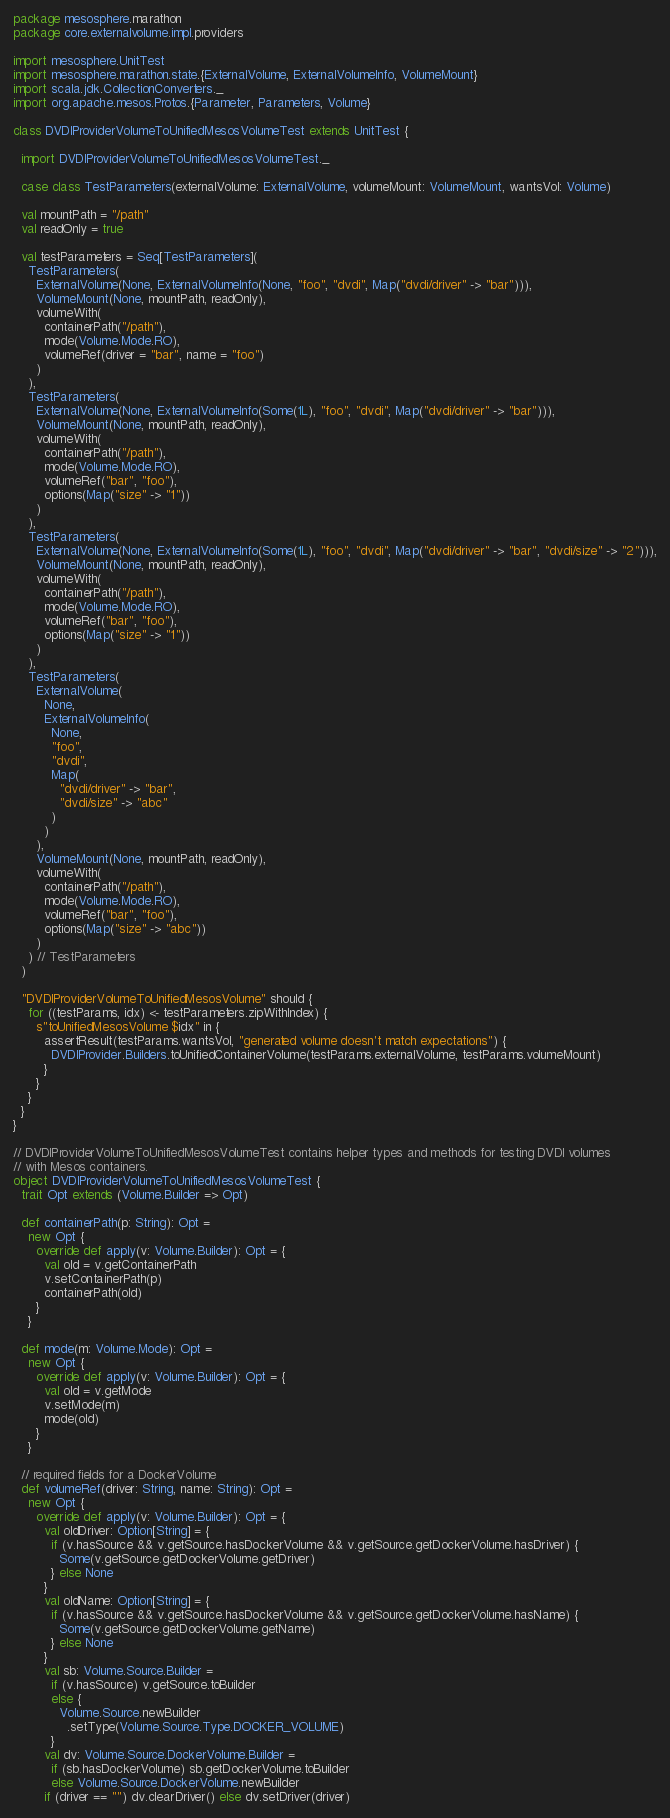Convert code to text. <code><loc_0><loc_0><loc_500><loc_500><_Scala_>package mesosphere.marathon
package core.externalvolume.impl.providers

import mesosphere.UnitTest
import mesosphere.marathon.state.{ExternalVolume, ExternalVolumeInfo, VolumeMount}
import scala.jdk.CollectionConverters._
import org.apache.mesos.Protos.{Parameter, Parameters, Volume}

class DVDIProviderVolumeToUnifiedMesosVolumeTest extends UnitTest {

  import DVDIProviderVolumeToUnifiedMesosVolumeTest._

  case class TestParameters(externalVolume: ExternalVolume, volumeMount: VolumeMount, wantsVol: Volume)

  val mountPath = "/path"
  val readOnly = true

  val testParameters = Seq[TestParameters](
    TestParameters(
      ExternalVolume(None, ExternalVolumeInfo(None, "foo", "dvdi", Map("dvdi/driver" -> "bar"))),
      VolumeMount(None, mountPath, readOnly),
      volumeWith(
        containerPath("/path"),
        mode(Volume.Mode.RO),
        volumeRef(driver = "bar", name = "foo")
      )
    ),
    TestParameters(
      ExternalVolume(None, ExternalVolumeInfo(Some(1L), "foo", "dvdi", Map("dvdi/driver" -> "bar"))),
      VolumeMount(None, mountPath, readOnly),
      volumeWith(
        containerPath("/path"),
        mode(Volume.Mode.RO),
        volumeRef("bar", "foo"),
        options(Map("size" -> "1"))
      )
    ),
    TestParameters(
      ExternalVolume(None, ExternalVolumeInfo(Some(1L), "foo", "dvdi", Map("dvdi/driver" -> "bar", "dvdi/size" -> "2"))),
      VolumeMount(None, mountPath, readOnly),
      volumeWith(
        containerPath("/path"),
        mode(Volume.Mode.RO),
        volumeRef("bar", "foo"),
        options(Map("size" -> "1"))
      )
    ),
    TestParameters(
      ExternalVolume(
        None,
        ExternalVolumeInfo(
          None,
          "foo",
          "dvdi",
          Map(
            "dvdi/driver" -> "bar",
            "dvdi/size" -> "abc"
          )
        )
      ),
      VolumeMount(None, mountPath, readOnly),
      volumeWith(
        containerPath("/path"),
        mode(Volume.Mode.RO),
        volumeRef("bar", "foo"),
        options(Map("size" -> "abc"))
      )
    ) // TestParameters
  )

  "DVDIProviderVolumeToUnifiedMesosVolume" should {
    for ((testParams, idx) <- testParameters.zipWithIndex) {
      s"toUnifiedMesosVolume $idx" in {
        assertResult(testParams.wantsVol, "generated volume doesn't match expectations") {
          DVDIProvider.Builders.toUnifiedContainerVolume(testParams.externalVolume, testParams.volumeMount)
        }
      }
    }
  }
}

// DVDIProviderVolumeToUnifiedMesosVolumeTest contains helper types and methods for testing DVDI volumes
// with Mesos containers.
object DVDIProviderVolumeToUnifiedMesosVolumeTest {
  trait Opt extends (Volume.Builder => Opt)

  def containerPath(p: String): Opt =
    new Opt {
      override def apply(v: Volume.Builder): Opt = {
        val old = v.getContainerPath
        v.setContainerPath(p)
        containerPath(old)
      }
    }

  def mode(m: Volume.Mode): Opt =
    new Opt {
      override def apply(v: Volume.Builder): Opt = {
        val old = v.getMode
        v.setMode(m)
        mode(old)
      }
    }

  // required fields for a DockerVolume
  def volumeRef(driver: String, name: String): Opt =
    new Opt {
      override def apply(v: Volume.Builder): Opt = {
        val oldDriver: Option[String] = {
          if (v.hasSource && v.getSource.hasDockerVolume && v.getSource.getDockerVolume.hasDriver) {
            Some(v.getSource.getDockerVolume.getDriver)
          } else None
        }
        val oldName: Option[String] = {
          if (v.hasSource && v.getSource.hasDockerVolume && v.getSource.getDockerVolume.hasName) {
            Some(v.getSource.getDockerVolume.getName)
          } else None
        }
        val sb: Volume.Source.Builder =
          if (v.hasSource) v.getSource.toBuilder
          else {
            Volume.Source.newBuilder
              .setType(Volume.Source.Type.DOCKER_VOLUME)
          }
        val dv: Volume.Source.DockerVolume.Builder =
          if (sb.hasDockerVolume) sb.getDockerVolume.toBuilder
          else Volume.Source.DockerVolume.newBuilder
        if (driver == "") dv.clearDriver() else dv.setDriver(driver)</code> 